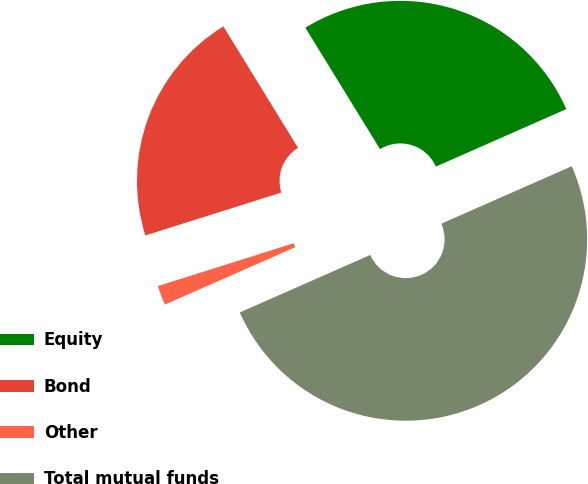Convert chart to OTSL. <chart><loc_0><loc_0><loc_500><loc_500><pie_chart><fcel>Equity<fcel>Bond<fcel>Other<fcel>Total mutual funds<nl><fcel>27.17%<fcel>21.09%<fcel>1.74%<fcel>50.0%<nl></chart> 